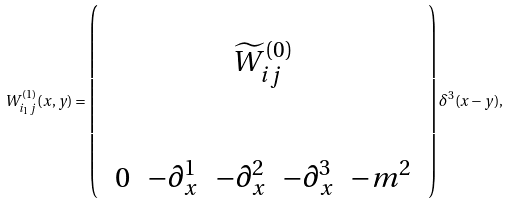Convert formula to latex. <formula><loc_0><loc_0><loc_500><loc_500>W ^ { ( 1 ) } _ { i _ { 1 } j } ( x , y ) = \left ( \begin{array} { c c } \\ \widetilde { W } ^ { ( 0 ) } _ { i j } \\ \\ \\ \begin{array} { c c c c c } 0 & - \partial ^ { 1 } _ { x } & - \partial ^ { 2 } _ { x } & - \partial ^ { 3 } _ { x } & - m ^ { 2 } \end{array} \end{array} \right ) \delta ^ { 3 } ( x - y ) ,</formula> 